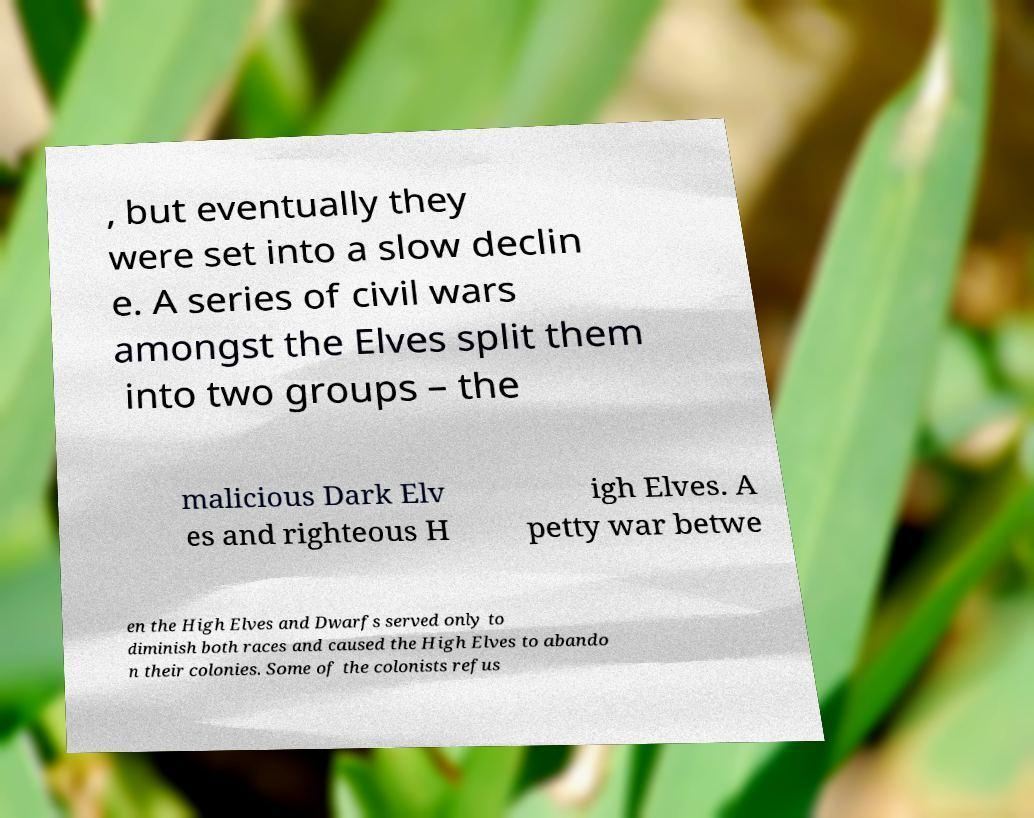Can you accurately transcribe the text from the provided image for me? , but eventually they were set into a slow declin e. A series of civil wars amongst the Elves split them into two groups – the malicious Dark Elv es and righteous H igh Elves. A petty war betwe en the High Elves and Dwarfs served only to diminish both races and caused the High Elves to abando n their colonies. Some of the colonists refus 